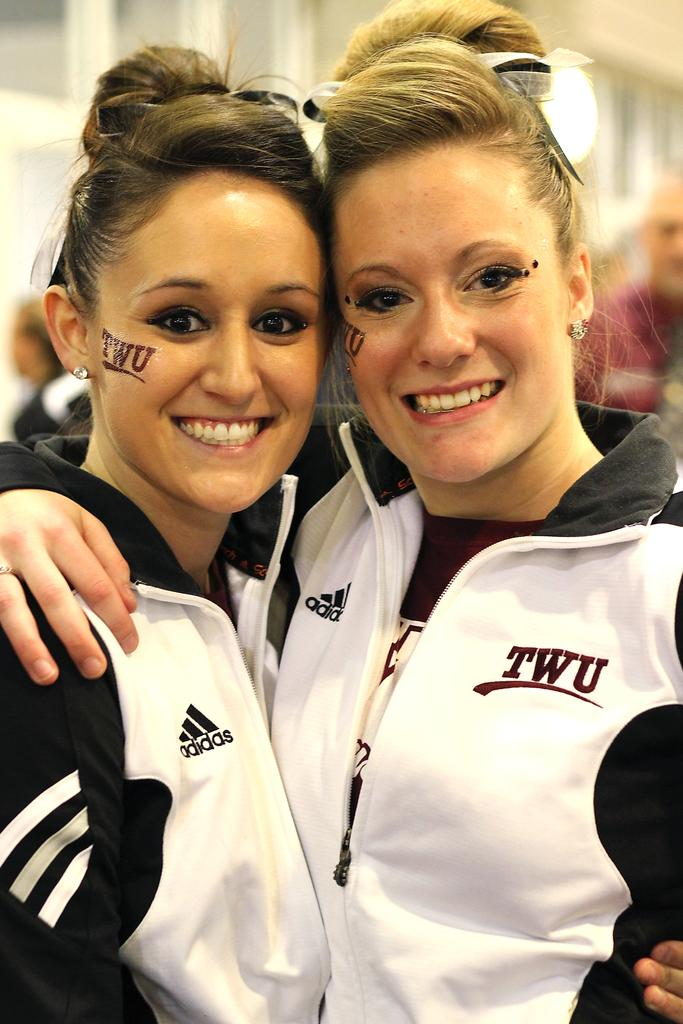<image>
Render a clear and concise summary of the photo. Two women posing for a photo with one wearing a tattoo on her face saying TWU. 